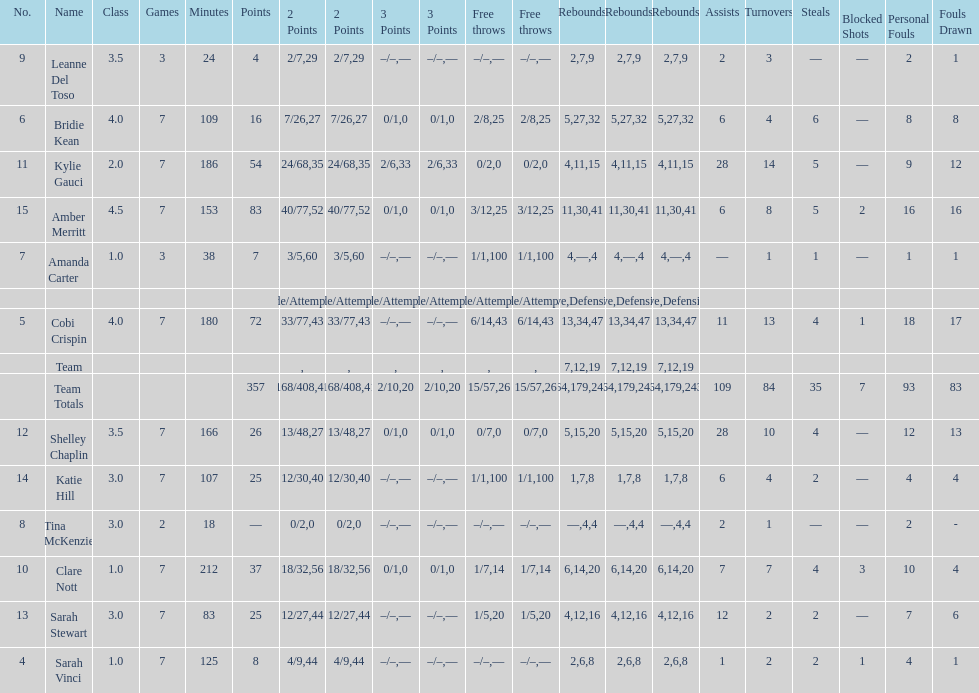Next to merritt, who was the top scorer? Cobi Crispin. 